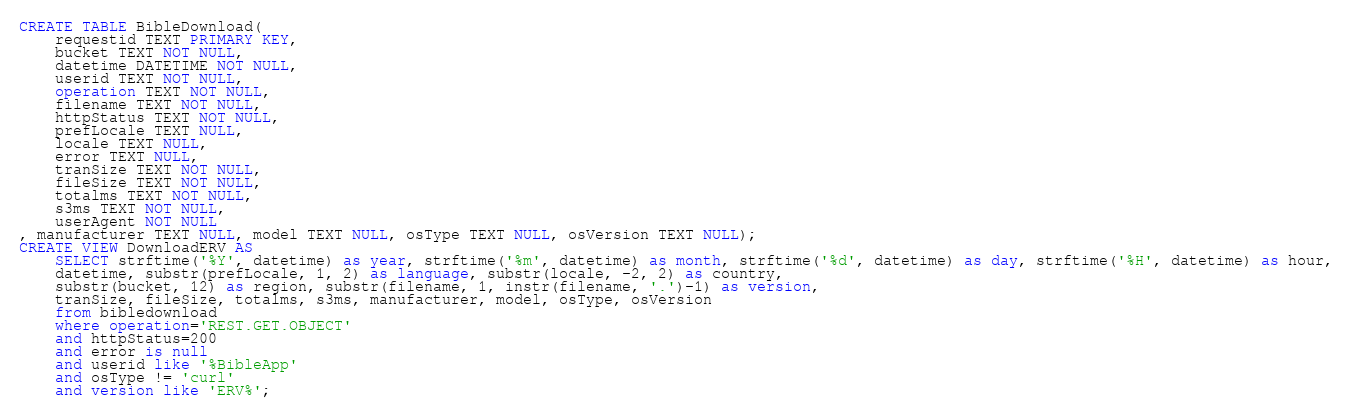<code> <loc_0><loc_0><loc_500><loc_500><_SQL_>CREATE TABLE BibleDownload(
	requestid TEXT PRIMARY KEY,
	bucket TEXT NOT NULL,
	datetime DATETIME NOT NULL,
	userid TEXT NOT NULL,
	operation TEXT NOT NULL,
	filename TEXT NOT NULL,
	httpStatus TEXT NOT NULL,
	prefLocale TEXT NULL,
	locale TEXT NULL,
	error TEXT NULL, 
	tranSize TEXT NOT NULL, 
	fileSize TEXT NOT NULL, 
	totalms TEXT NOT NULL, 
	s3ms TEXT NOT NULL, 
	userAgent NOT NULL 	
, manufacturer TEXT NULL, model TEXT NULL, osType TEXT NULL, osVersion TEXT NULL);
CREATE VIEW DownloadERV AS
	SELECT strftime('%Y', datetime) as year, strftime('%m', datetime) as month, strftime('%d', datetime) as day, strftime('%H', datetime) as hour,
	datetime, substr(prefLocale, 1, 2) as language, substr(locale, -2, 2) as country,
	substr(bucket, 12) as region, substr(filename, 1, instr(filename, '.')-1) as version,
	tranSize, fileSize, totalms, s3ms, manufacturer, model, osType, osVersion
	from bibledownload 
	where operation='REST.GET.OBJECT' 
	and httpStatus=200
	and error is null
	and userid like '%BibleApp'
	and osType != 'curl'
	and version like 'ERV%';</code> 